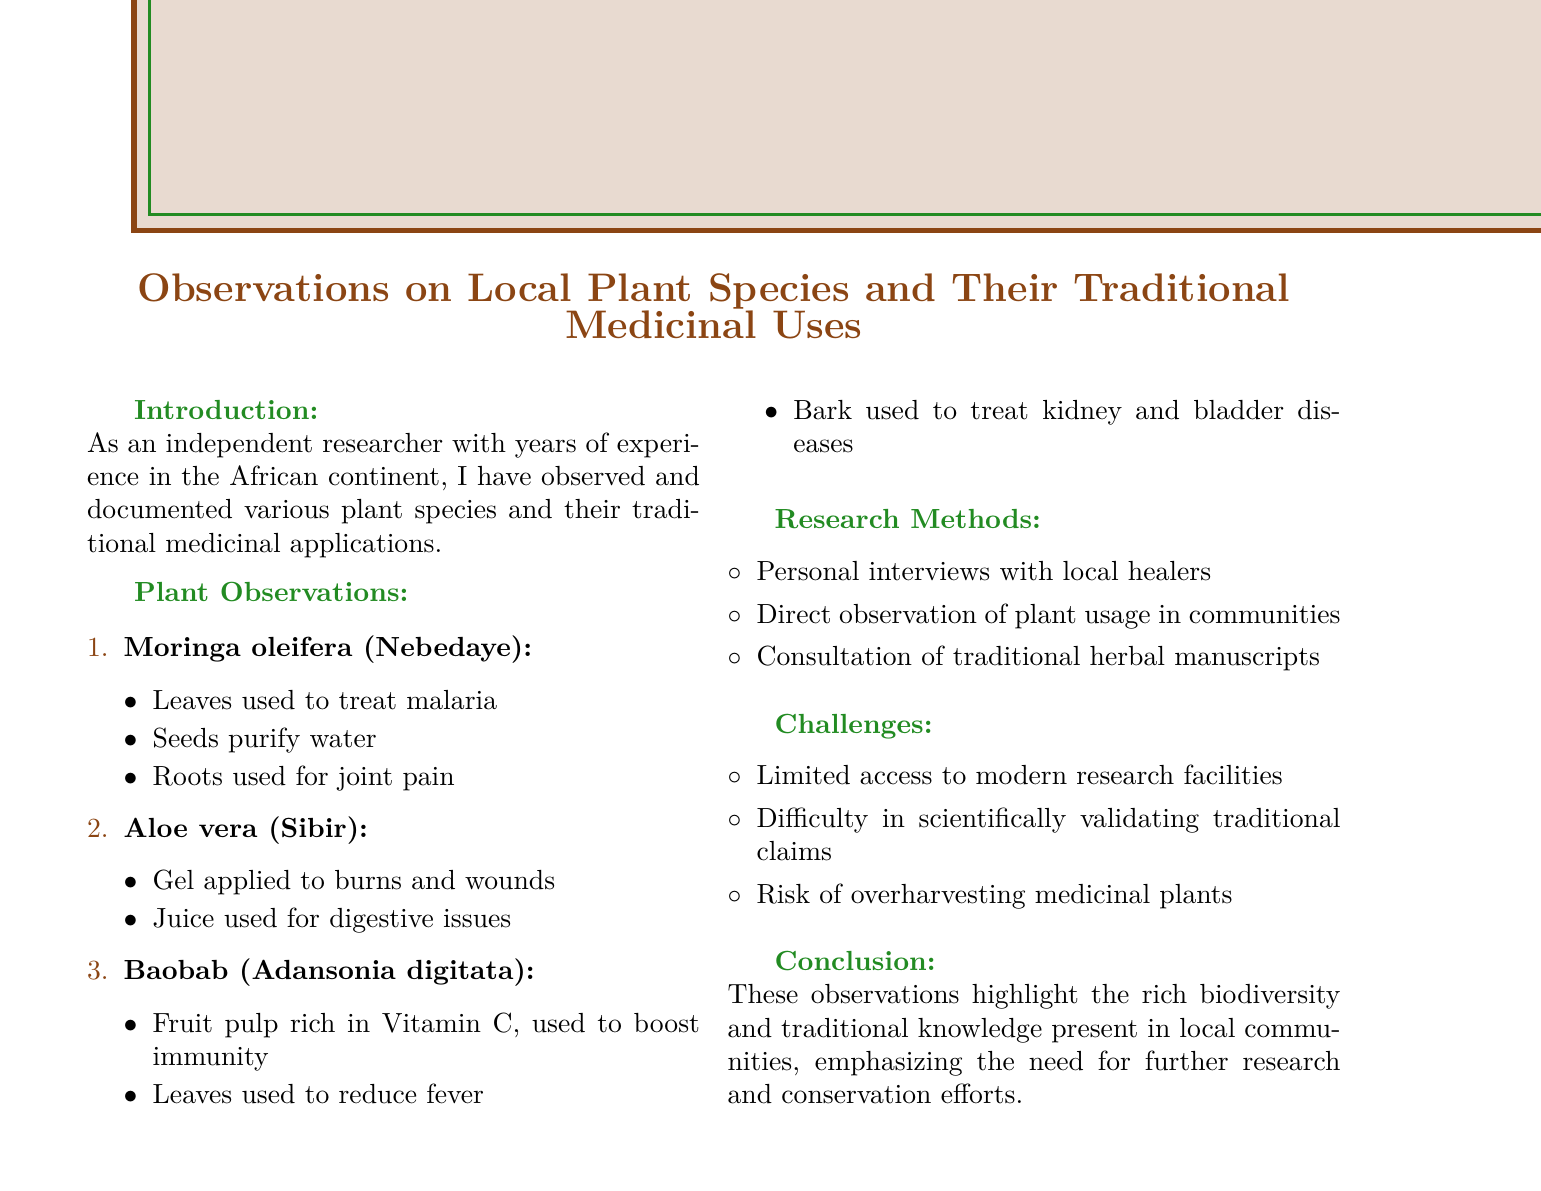What is the title of the document? The title is the heading that introduces the main topic of the document.
Answer: Observations on Local Plant Species and Their Traditional Medicinal Uses What is the local name for Moringa oleifera? The local name is provided for each plant species in the observations section, specifically linked to Moringa oleifera.
Answer: Nebedaye How many medicinal uses are listed for Aloe vera? The number of medicinal uses can be determined by counting the listed applications under Aloe vera in the document.
Answer: 2 What is one challenge mentioned in the document? Challenges are listed in a specific section, and the task is to identify any of those challenges directly from the text.
Answer: Limited access to modern research facilities Which plant's fruit pulp is rich in Vitamin C? This information can be found under the specific plant observations related to nutritional content.
Answer: Baobab What research method involves consulting traditional herbal manuscripts? This method is specified within the research methods section, indicating its significance in the study.
Answer: Consultation of traditional herbal manuscripts How many plants are observed in the document? The total number of plants can be calculated based on the listing provided in the plant observations section.
Answer: 3 What type of knowledge is highlighted in the conclusion? The conclusion emphasizes an important aspect of the research findings.
Answer: Traditional knowledge What is the main focus of the document? This can be inferred from the title and introduction, summarizing the primary theme of the report.
Answer: Traditional medicinal uses 